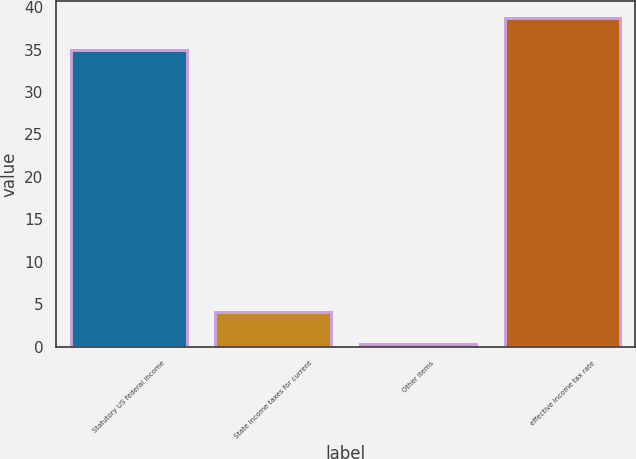Convert chart. <chart><loc_0><loc_0><loc_500><loc_500><bar_chart><fcel>Statutory US federal income<fcel>State income taxes for current<fcel>Other items<fcel>effective income tax rate<nl><fcel>35<fcel>4.04<fcel>0.3<fcel>38.74<nl></chart> 